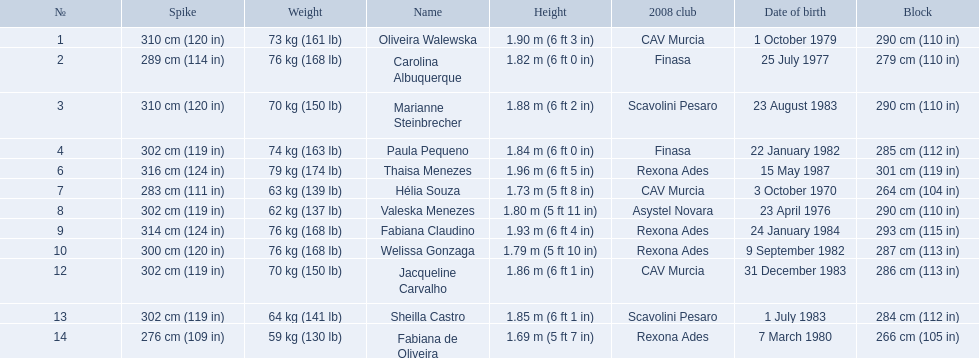What are the names of all the contestants? Oliveira Walewska, Carolina Albuquerque, Marianne Steinbrecher, Paula Pequeno, Thaisa Menezes, Hélia Souza, Valeska Menezes, Fabiana Claudino, Welissa Gonzaga, Jacqueline Carvalho, Sheilla Castro, Fabiana de Oliveira. What are the weight ranges of the contestants? 73 kg (161 lb), 76 kg (168 lb), 70 kg (150 lb), 74 kg (163 lb), 79 kg (174 lb), 63 kg (139 lb), 62 kg (137 lb), 76 kg (168 lb), 76 kg (168 lb), 70 kg (150 lb), 64 kg (141 lb), 59 kg (130 lb). Which player is heaviest. sheilla castro, fabiana de oliveira, or helia souza? Sheilla Castro. 